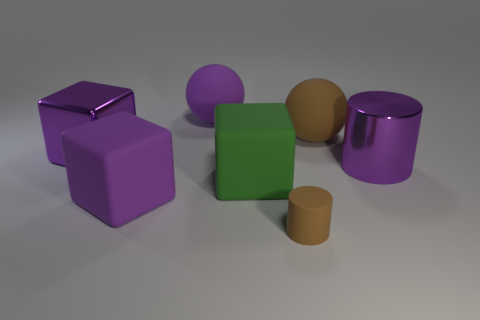Subtract all red spheres. Subtract all green cylinders. How many spheres are left? 2 Add 2 purple rubber balls. How many objects exist? 9 Subtract all cylinders. How many objects are left? 5 Subtract all large yellow objects. Subtract all brown balls. How many objects are left? 6 Add 4 matte cylinders. How many matte cylinders are left? 5 Add 7 red matte cubes. How many red matte cubes exist? 7 Subtract 1 brown cylinders. How many objects are left? 6 